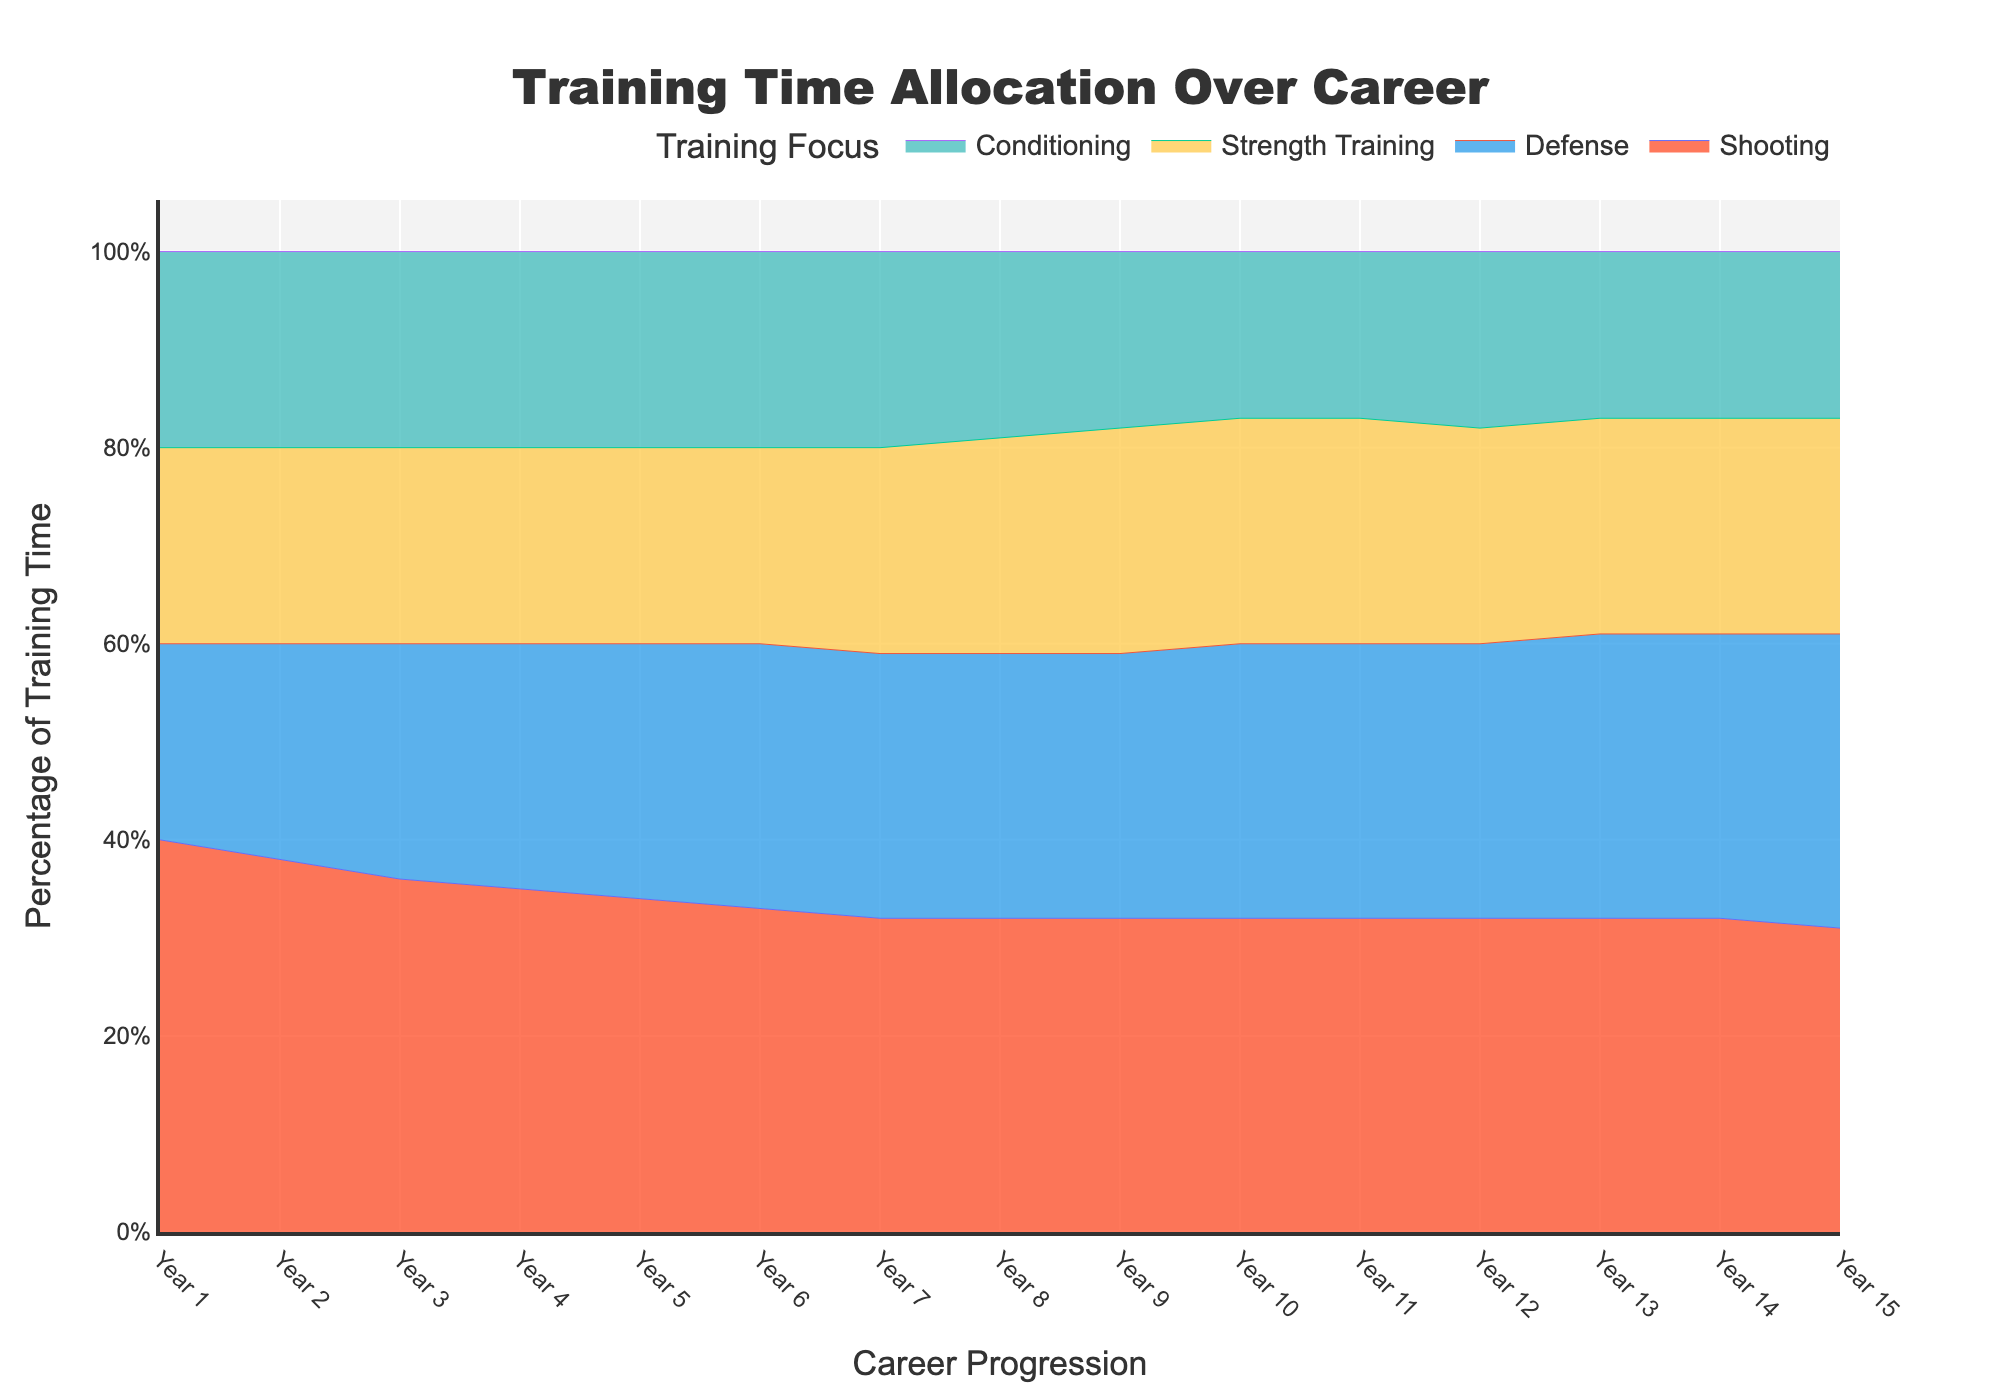What is the title of the chart? The title of the chart is located at the top of the figure. It visually represents the main topic of the chart.
Answer: Training Time Allocation Over Career Which category starts with the highest percentage in Year 1? By observing the 100% Stacked Area Chart, the category with the largest area at the beginning (left side) of the chart represents the highest percentage.
Answer: Shooting How does the percentage allocation for Defense change over the career? By visually tracking the color associated with Defense (blue) from left to right, you observe how its area grows over time. The area for Defense gradually increases from 20% in Year 1 to 30% in Year 15.
Answer: Increases In which year does Strength Training first deviate from 20%? Examine the color area representing Strength Training (yellow). The deviation point can be identified where the area's height changes from a constant 20% to another value.
Answer: Year 7 What is the percentage allocation for Conditioning in Year 10? Go to the location on the x-axis representing Year 10 and refer vertically to the area representing Conditioning (teal). The percentage is the height of this area.
Answer: 17% In which year does Conditioning have its lowest percentage? Track the teal color area representing Conditioning and identify the lowest point visually on the y-axis. This can be cross-referenced with the corresponding year on the x-axis.
Answer: Year 15 How does the percentage allocation for Shooting change from Year 1 to Year 15? Observe the red area representing Shooting at the start (Year 1) and end (Year 15) of the chart and note the height of its area at these points. Shooting decreases from 40% in Year 1 to 31% in Year 15.
Answer: Decreases What is the combined percentage for Defense and Conditioning in Year 8? Identify the percentage for Defense and Conditioning in Year 8 individually and sum these values. Defense is 27% and Conditioning is 19%, combining to a total of 46%.
Answer: 46% Which year shows an equal percentage allocation for Shooting and Defense? Look for overlapping areas where the heights of the Defense (blue) and Shooting (red) areas are equal. This occurs in Year 6.
Answer: Year 6 Does Strength Training ever exceed the percentage allocation of Shooting? Compare the yellow area (Strength Training) with the red area (Shooting) across the entire chart to check if Strength Training area surpasses Shooting. It does not exceed at any point.
Answer: No 